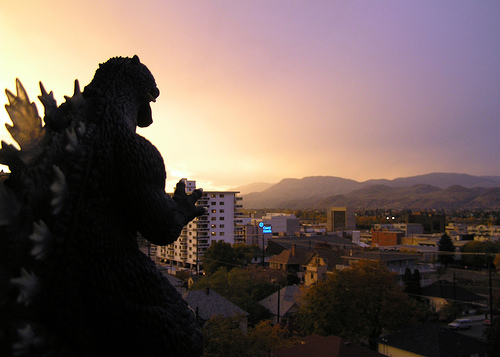<image>
Is the sky behind the mountain? Yes. From this viewpoint, the sky is positioned behind the mountain, with the mountain partially or fully occluding the sky. 